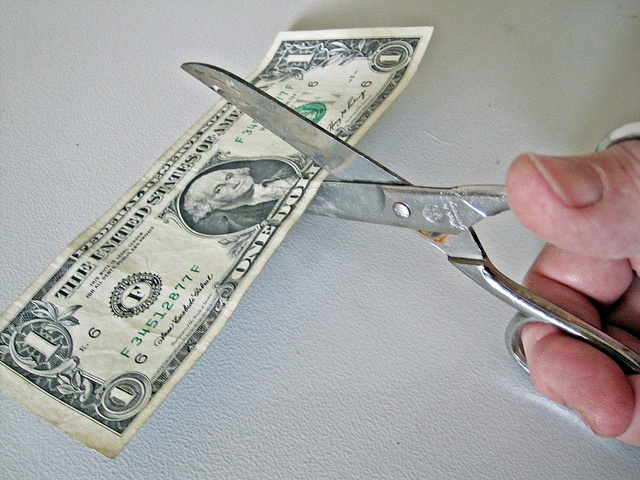Describe the objects in this image and their specific colors. I can see people in darkgray, brown, lightpink, and maroon tones and scissors in darkgray, gray, black, and lightgray tones in this image. 